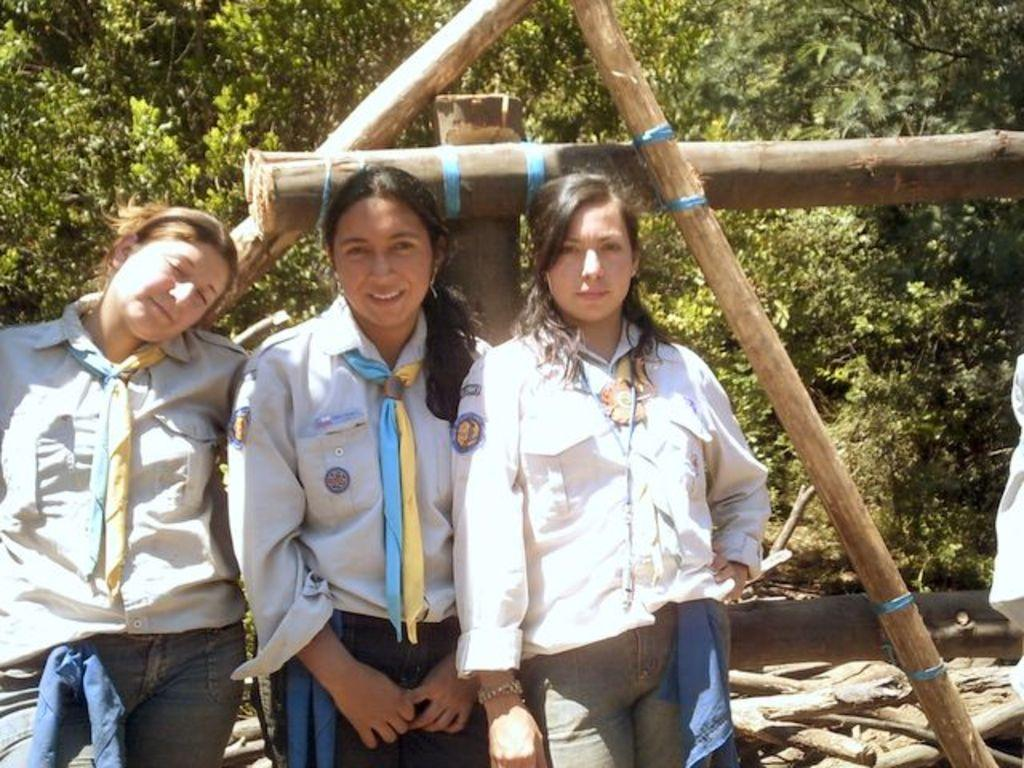How many people are in the image? There are three ladies standing in the center of the image. What can be seen in the background of the image? There are trees, logs, and grass in the background of the image. What is the condition of the swing in the image? There is no swing present in the image. How many trails can be seen in the image? There are no trails visible in the image. 